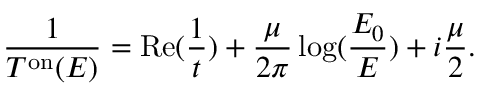<formula> <loc_0><loc_0><loc_500><loc_500>\frac { 1 } { T ^ { o n } ( E ) } = R e ( \frac { 1 } { t } ) + \frac { \mu } { 2 \pi } \log ( \frac { E _ { 0 } } { E } ) + i \frac { \mu } { 2 } .</formula> 